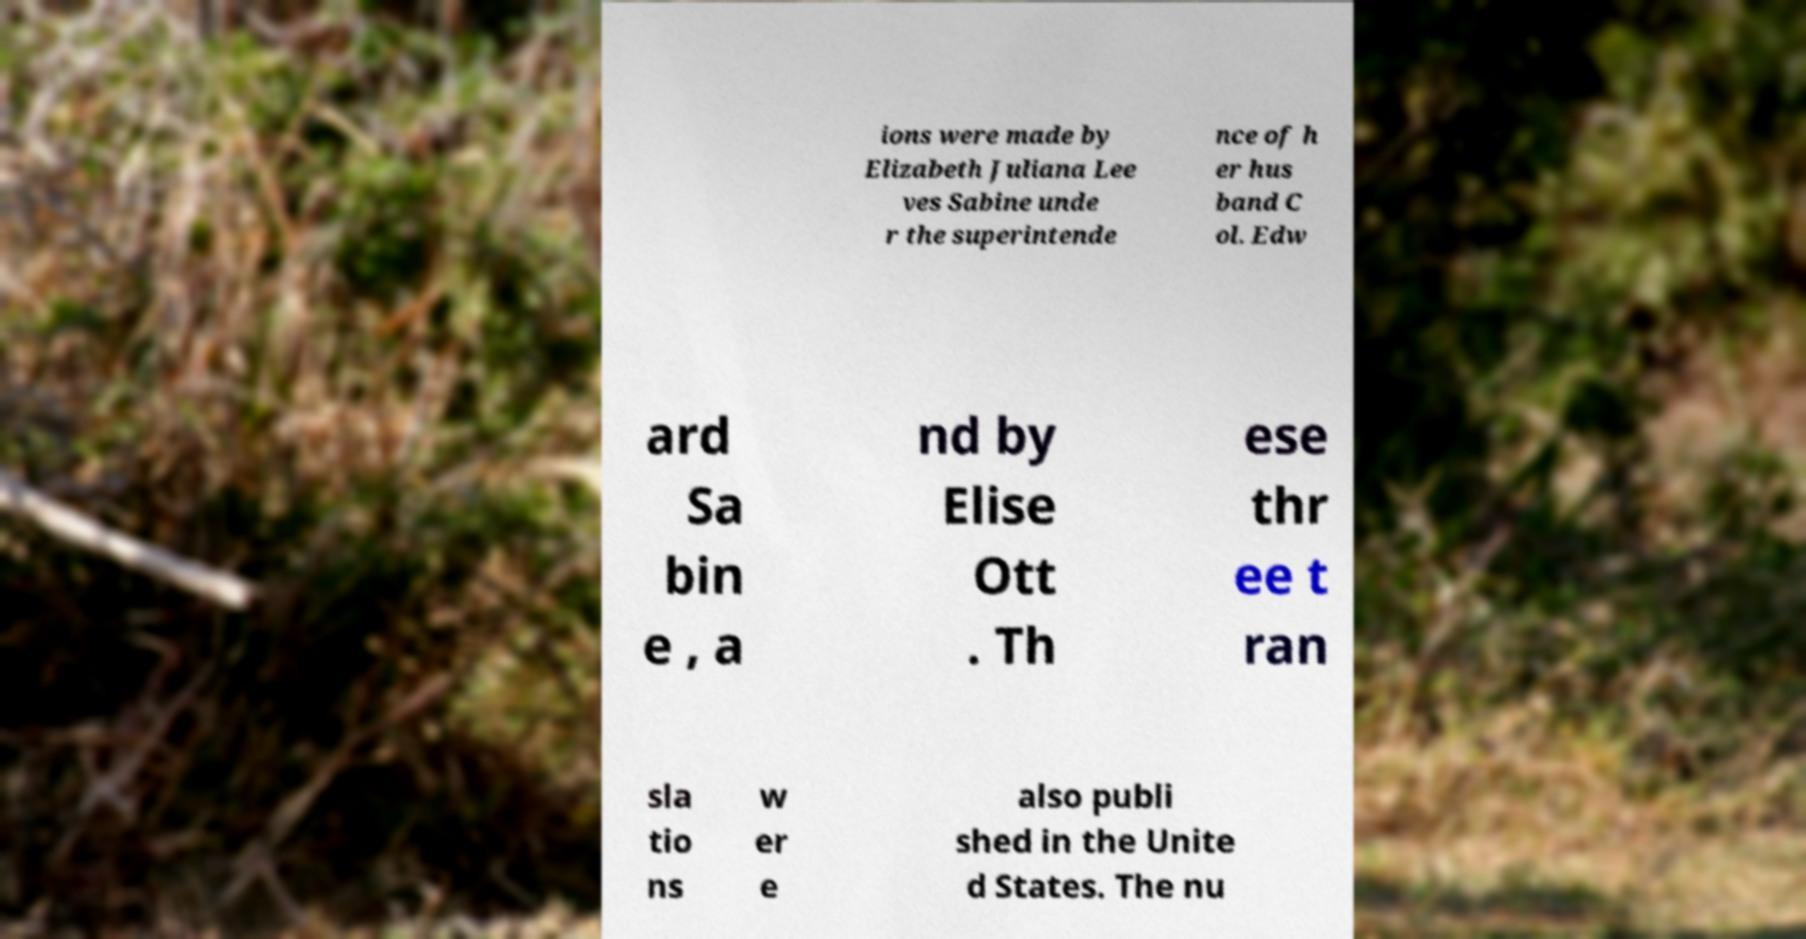What messages or text are displayed in this image? I need them in a readable, typed format. ions were made by Elizabeth Juliana Lee ves Sabine unde r the superintende nce of h er hus band C ol. Edw ard Sa bin e , a nd by Elise Ott . Th ese thr ee t ran sla tio ns w er e also publi shed in the Unite d States. The nu 